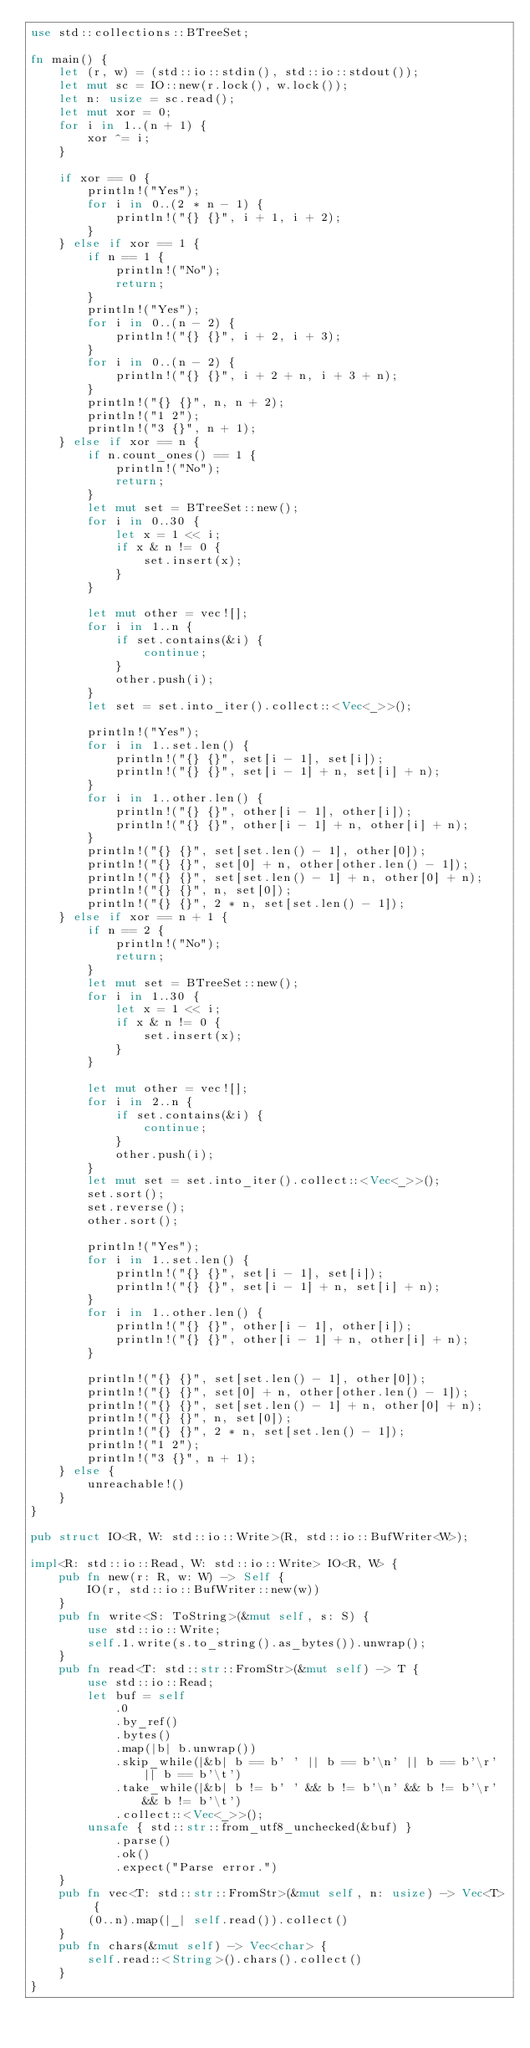Convert code to text. <code><loc_0><loc_0><loc_500><loc_500><_Rust_>use std::collections::BTreeSet;

fn main() {
    let (r, w) = (std::io::stdin(), std::io::stdout());
    let mut sc = IO::new(r.lock(), w.lock());
    let n: usize = sc.read();
    let mut xor = 0;
    for i in 1..(n + 1) {
        xor ^= i;
    }

    if xor == 0 {
        println!("Yes");
        for i in 0..(2 * n - 1) {
            println!("{} {}", i + 1, i + 2);
        }
    } else if xor == 1 {
        if n == 1 {
            println!("No");
            return;
        }
        println!("Yes");
        for i in 0..(n - 2) {
            println!("{} {}", i + 2, i + 3);
        }
        for i in 0..(n - 2) {
            println!("{} {}", i + 2 + n, i + 3 + n);
        }
        println!("{} {}", n, n + 2);
        println!("1 2");
        println!("3 {}", n + 1);
    } else if xor == n {
        if n.count_ones() == 1 {
            println!("No");
            return;
        }
        let mut set = BTreeSet::new();
        for i in 0..30 {
            let x = 1 << i;
            if x & n != 0 {
                set.insert(x);
            }
        }

        let mut other = vec![];
        for i in 1..n {
            if set.contains(&i) {
                continue;
            }
            other.push(i);
        }
        let set = set.into_iter().collect::<Vec<_>>();

        println!("Yes");
        for i in 1..set.len() {
            println!("{} {}", set[i - 1], set[i]);
            println!("{} {}", set[i - 1] + n, set[i] + n);
        }
        for i in 1..other.len() {
            println!("{} {}", other[i - 1], other[i]);
            println!("{} {}", other[i - 1] + n, other[i] + n);
        }
        println!("{} {}", set[set.len() - 1], other[0]);
        println!("{} {}", set[0] + n, other[other.len() - 1]);
        println!("{} {}", set[set.len() - 1] + n, other[0] + n);
        println!("{} {}", n, set[0]);
        println!("{} {}", 2 * n, set[set.len() - 1]);
    } else if xor == n + 1 {
        if n == 2 {
            println!("No");
            return;
        }
        let mut set = BTreeSet::new();
        for i in 1..30 {
            let x = 1 << i;
            if x & n != 0 {
                set.insert(x);
            }
        }

        let mut other = vec![];
        for i in 2..n {
            if set.contains(&i) {
                continue;
            }
            other.push(i);
        }
        let mut set = set.into_iter().collect::<Vec<_>>();
        set.sort();
        set.reverse();
        other.sort();

        println!("Yes");
        for i in 1..set.len() {
            println!("{} {}", set[i - 1], set[i]);
            println!("{} {}", set[i - 1] + n, set[i] + n);
        }
        for i in 1..other.len() {
            println!("{} {}", other[i - 1], other[i]);
            println!("{} {}", other[i - 1] + n, other[i] + n);
        }

        println!("{} {}", set[set.len() - 1], other[0]);
        println!("{} {}", set[0] + n, other[other.len() - 1]);
        println!("{} {}", set[set.len() - 1] + n, other[0] + n);
        println!("{} {}", n, set[0]);
        println!("{} {}", 2 * n, set[set.len() - 1]);
        println!("1 2");
        println!("3 {}", n + 1);
    } else {
        unreachable!()
    }
}

pub struct IO<R, W: std::io::Write>(R, std::io::BufWriter<W>);

impl<R: std::io::Read, W: std::io::Write> IO<R, W> {
    pub fn new(r: R, w: W) -> Self {
        IO(r, std::io::BufWriter::new(w))
    }
    pub fn write<S: ToString>(&mut self, s: S) {
        use std::io::Write;
        self.1.write(s.to_string().as_bytes()).unwrap();
    }
    pub fn read<T: std::str::FromStr>(&mut self) -> T {
        use std::io::Read;
        let buf = self
            .0
            .by_ref()
            .bytes()
            .map(|b| b.unwrap())
            .skip_while(|&b| b == b' ' || b == b'\n' || b == b'\r' || b == b'\t')
            .take_while(|&b| b != b' ' && b != b'\n' && b != b'\r' && b != b'\t')
            .collect::<Vec<_>>();
        unsafe { std::str::from_utf8_unchecked(&buf) }
            .parse()
            .ok()
            .expect("Parse error.")
    }
    pub fn vec<T: std::str::FromStr>(&mut self, n: usize) -> Vec<T> {
        (0..n).map(|_| self.read()).collect()
    }
    pub fn chars(&mut self) -> Vec<char> {
        self.read::<String>().chars().collect()
    }
}
</code> 